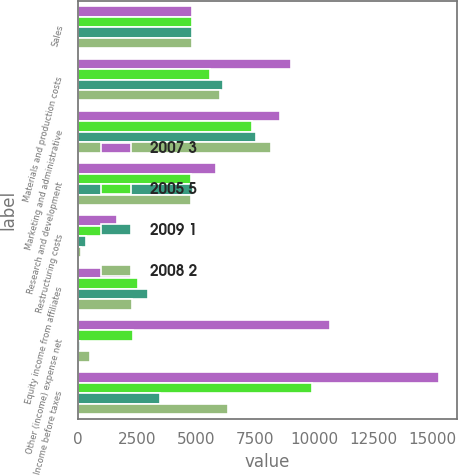Convert chart. <chart><loc_0><loc_0><loc_500><loc_500><stacked_bar_chart><ecel><fcel>Sales<fcel>Materials and production costs<fcel>Marketing and administrative<fcel>Research and development<fcel>Restructuring costs<fcel>Equity income from affiliates<fcel>Other (income) expense net<fcel>Income before taxes<nl><fcel>2007 3<fcel>4844.05<fcel>9018.9<fcel>8543.2<fcel>5845<fcel>1633.9<fcel>2235<fcel>10669.5<fcel>15291.8<nl><fcel>2005 5<fcel>4844.05<fcel>5582.5<fcel>7377<fcel>4805.3<fcel>1032.5<fcel>2560.6<fcel>2318.1<fcel>9931.7<nl><fcel>2009 1<fcel>4844.05<fcel>6140.7<fcel>7556.7<fcel>4882.8<fcel>327.1<fcel>2976.5<fcel>75.2<fcel>3492.1<nl><fcel>2008 2<fcel>4844.05<fcel>6001.1<fcel>8165.4<fcel>4782.9<fcel>142.3<fcel>2294.4<fcel>503.2<fcel>6341.9<nl></chart> 